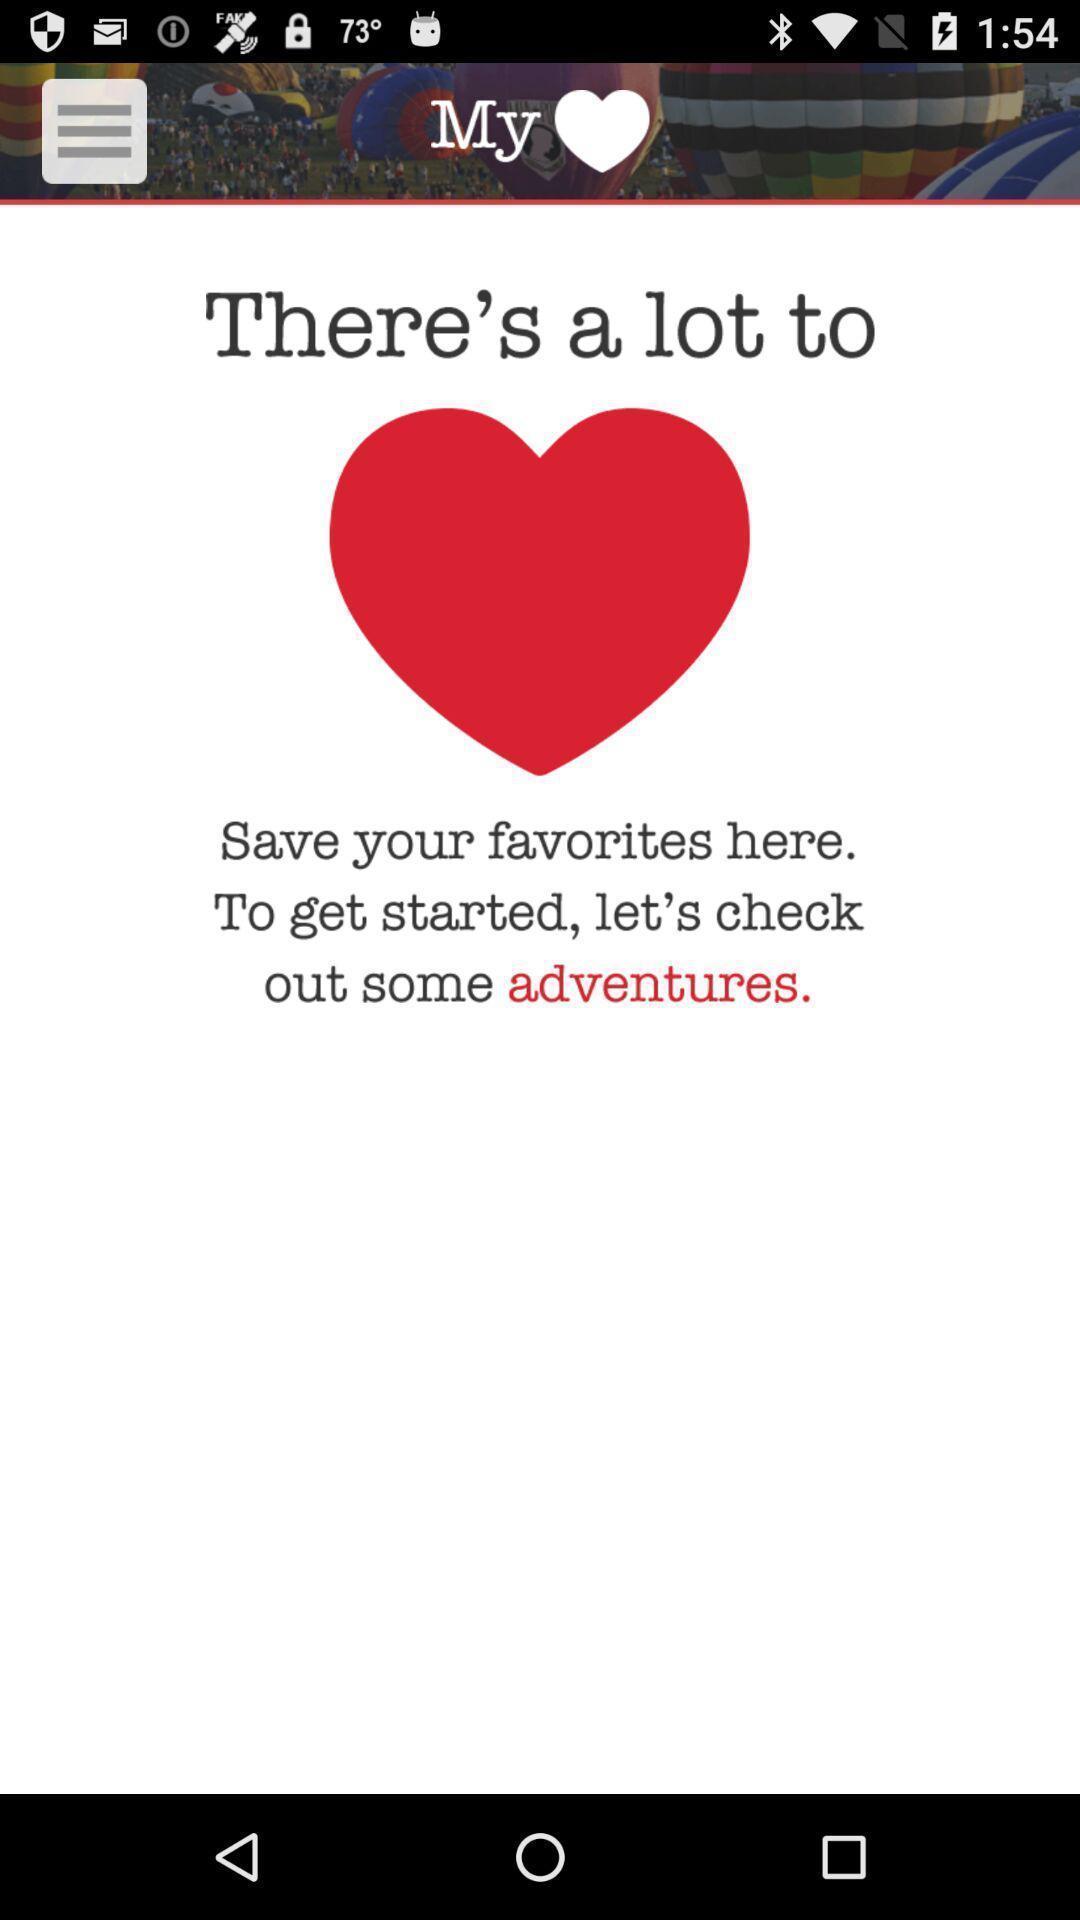Tell me what you see in this picture. Screen showing the option for favorites. 